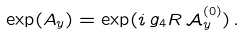<formula> <loc_0><loc_0><loc_500><loc_500>\exp ( A _ { y } ) = \exp ( i \, g _ { 4 } R \, \mathcal { A } _ { y } ^ { ( 0 ) } ) \, .</formula> 